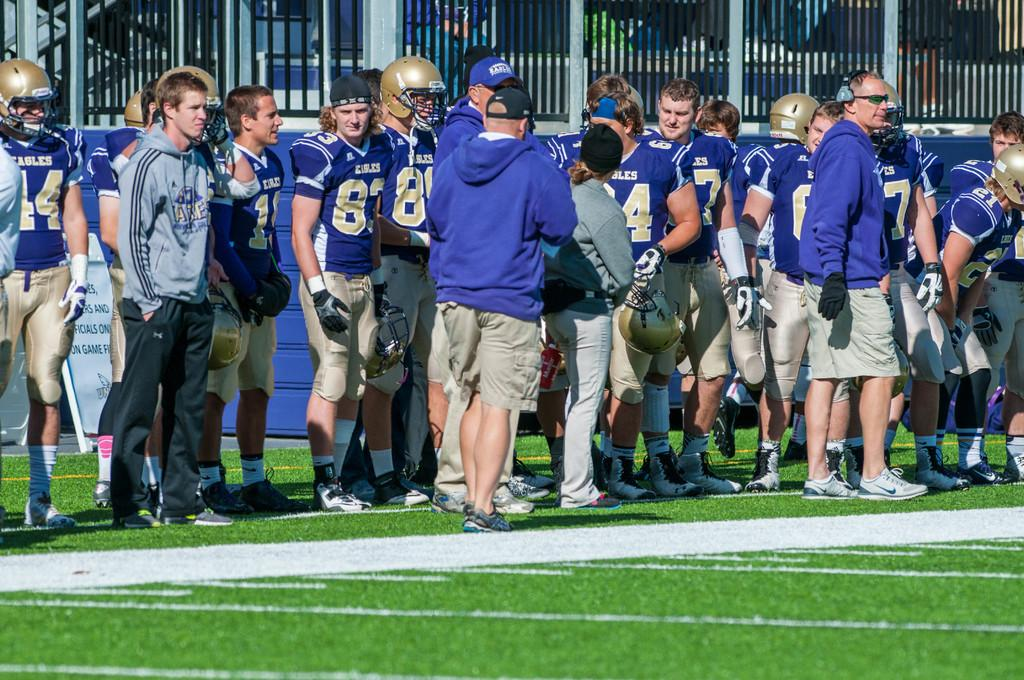How many people are in the image? There is a group of people in the image. What are the people wearing on their heads? The people are wearing helmets. What else are the people wearing? The people are also wearing gloves. What can be seen in the image besides the people? There is a board-like object in the image. What is visible in the background of the image? There are iron grilles in the background of the image. How many cakes are being served during the rainstorm in the image? There is no rainstorm or cakes present in the image. What type of pin is holding the people's gloves together in the image? There is no pin visible in the image; the people are wearing gloves separately. 